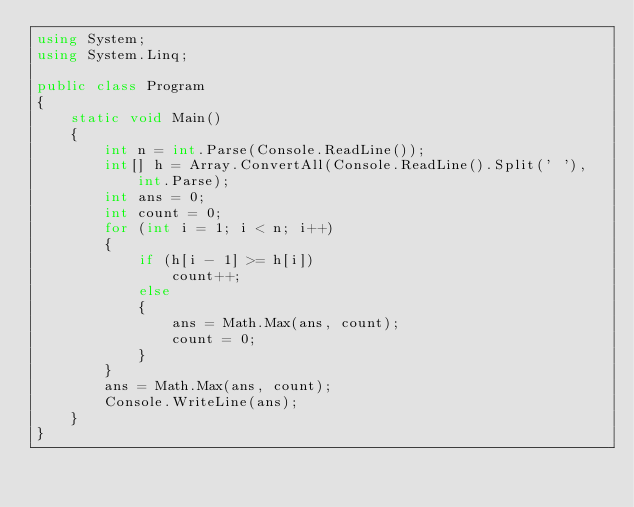<code> <loc_0><loc_0><loc_500><loc_500><_C#_>using System;
using System.Linq;

public class Program
{
    static void Main()
    {
        int n = int.Parse(Console.ReadLine());
        int[] h = Array.ConvertAll(Console.ReadLine().Split(' '), int.Parse);
        int ans = 0;
        int count = 0;
        for (int i = 1; i < n; i++)
        {
            if (h[i - 1] >= h[i])
                count++;
            else
            {
                ans = Math.Max(ans, count);
                count = 0;
            }
        }
        ans = Math.Max(ans, count);
        Console.WriteLine(ans);
    }
}</code> 